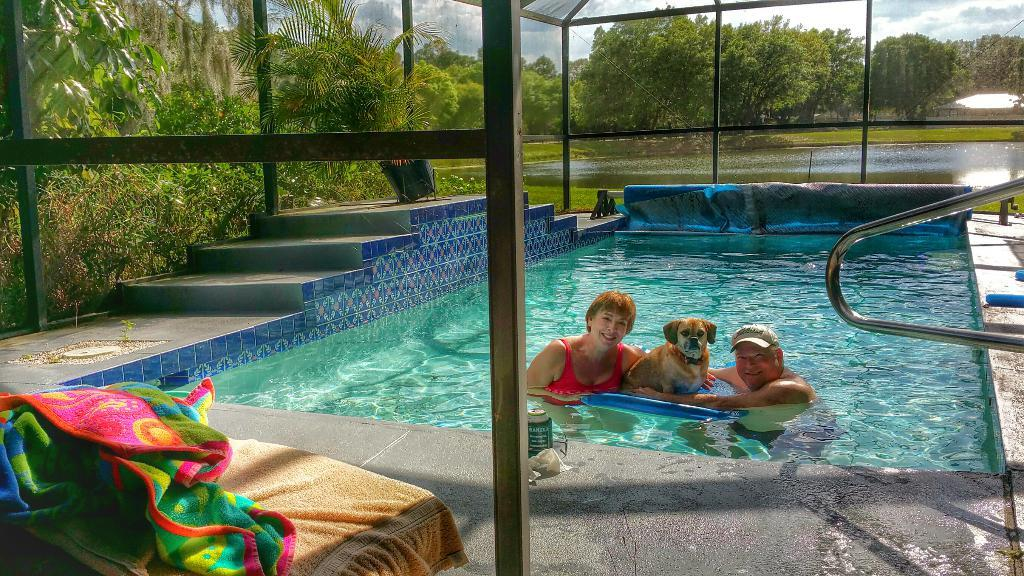How many people are in the image? There are two persons in the image. What are the persons doing in the image? The persons are in a pool. What other living creature is in the pool with them? There is a dog in the pool. Can you describe any architectural features in the image? Yes, there are stairs in the image. What item is present for drying off after swimming? There is a towel in the image. What type of vegetation is visible in the background of the image? There are trees at the back side of the image. Is there a volcano erupting in the background of the image? No, there is no volcano present in the image. What type of bean is being used as a pool float in the image? There are no beans or pool floats visible in the image. 